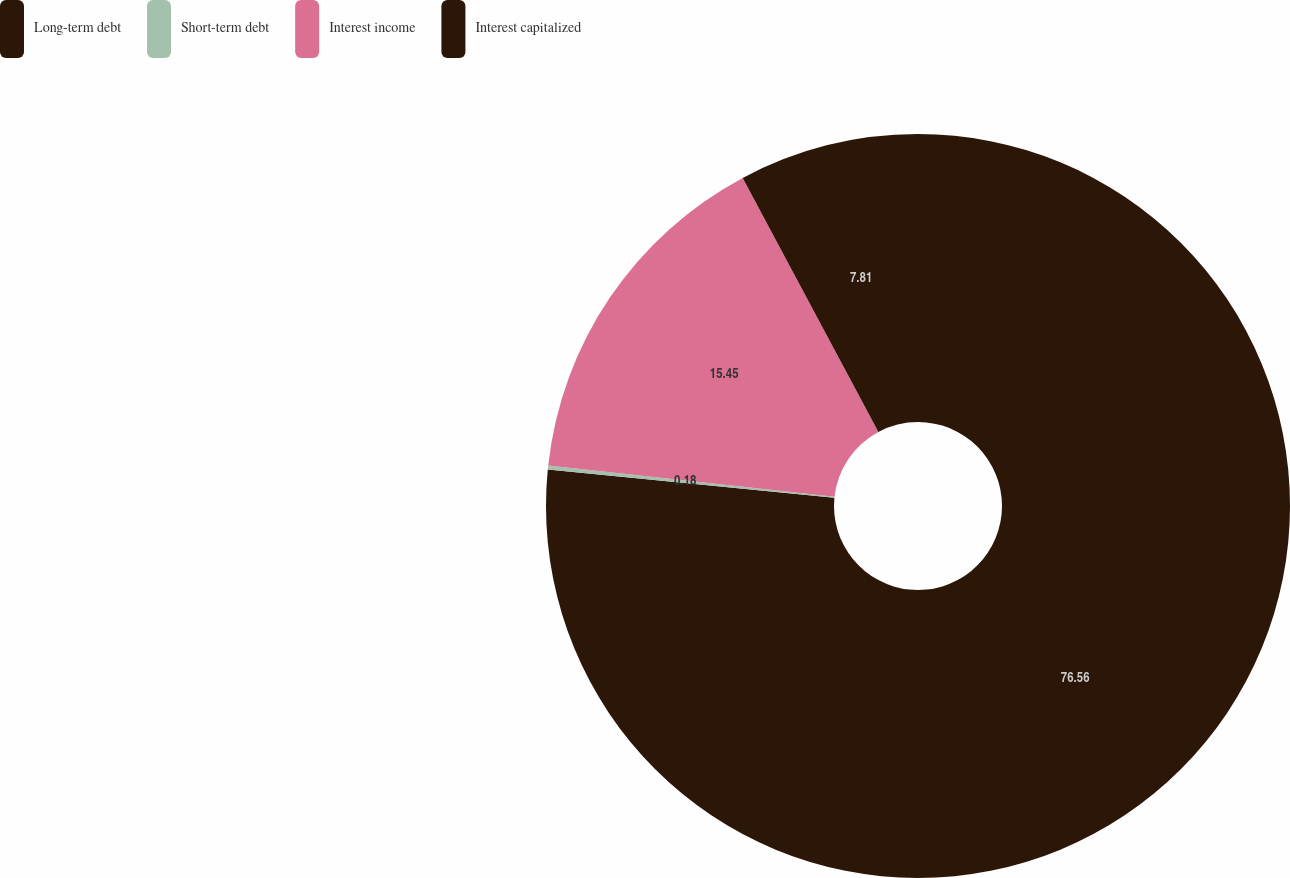Convert chart to OTSL. <chart><loc_0><loc_0><loc_500><loc_500><pie_chart><fcel>Long-term debt<fcel>Short-term debt<fcel>Interest income<fcel>Interest capitalized<nl><fcel>76.56%<fcel>0.18%<fcel>15.45%<fcel>7.81%<nl></chart> 